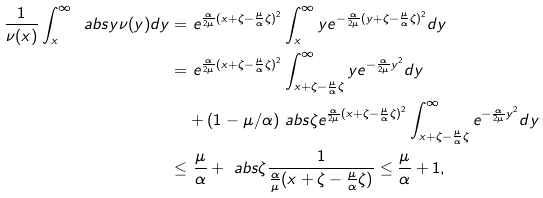Convert formula to latex. <formula><loc_0><loc_0><loc_500><loc_500>\frac { 1 } { \nu ( x ) } \int _ { x } ^ { \infty } \ a b s { y } \nu ( y ) d y = & \ e ^ { \frac { \alpha } { 2 \mu } ( x + \zeta - \frac { \mu } { \alpha } \zeta ) ^ { 2 } } \int _ { x } ^ { \infty } y e ^ { - \frac { \alpha } { 2 \mu } ( y + \zeta - \frac { \mu } { \alpha } \zeta ) ^ { 2 } } d y \\ = & \ e ^ { \frac { \alpha } { 2 \mu } ( x + \zeta - \frac { \mu } { \alpha } \zeta ) ^ { 2 } } \int _ { x + \zeta - \frac { \mu } { \alpha } \zeta } ^ { \infty } y e ^ { - \frac { \alpha } { 2 \mu } y ^ { 2 } } d y \\ & + ( 1 - \mu / \alpha ) \ a b s { \zeta } e ^ { \frac { \alpha } { 2 \mu } ( x + \zeta - \frac { \mu } { \alpha } \zeta ) ^ { 2 } } \int _ { x + \zeta - \frac { \mu } { \alpha } \zeta } ^ { \infty } e ^ { - \frac { \alpha } { 2 \mu } y ^ { 2 } } d y \\ \leq & \ \frac { \mu } { \alpha } + \ a b s { \zeta } \frac { 1 } { \frac { \alpha } { \mu } ( x + \zeta - \frac { \mu } { \alpha } \zeta ) } \leq \frac { \mu } { \alpha } + 1 ,</formula> 